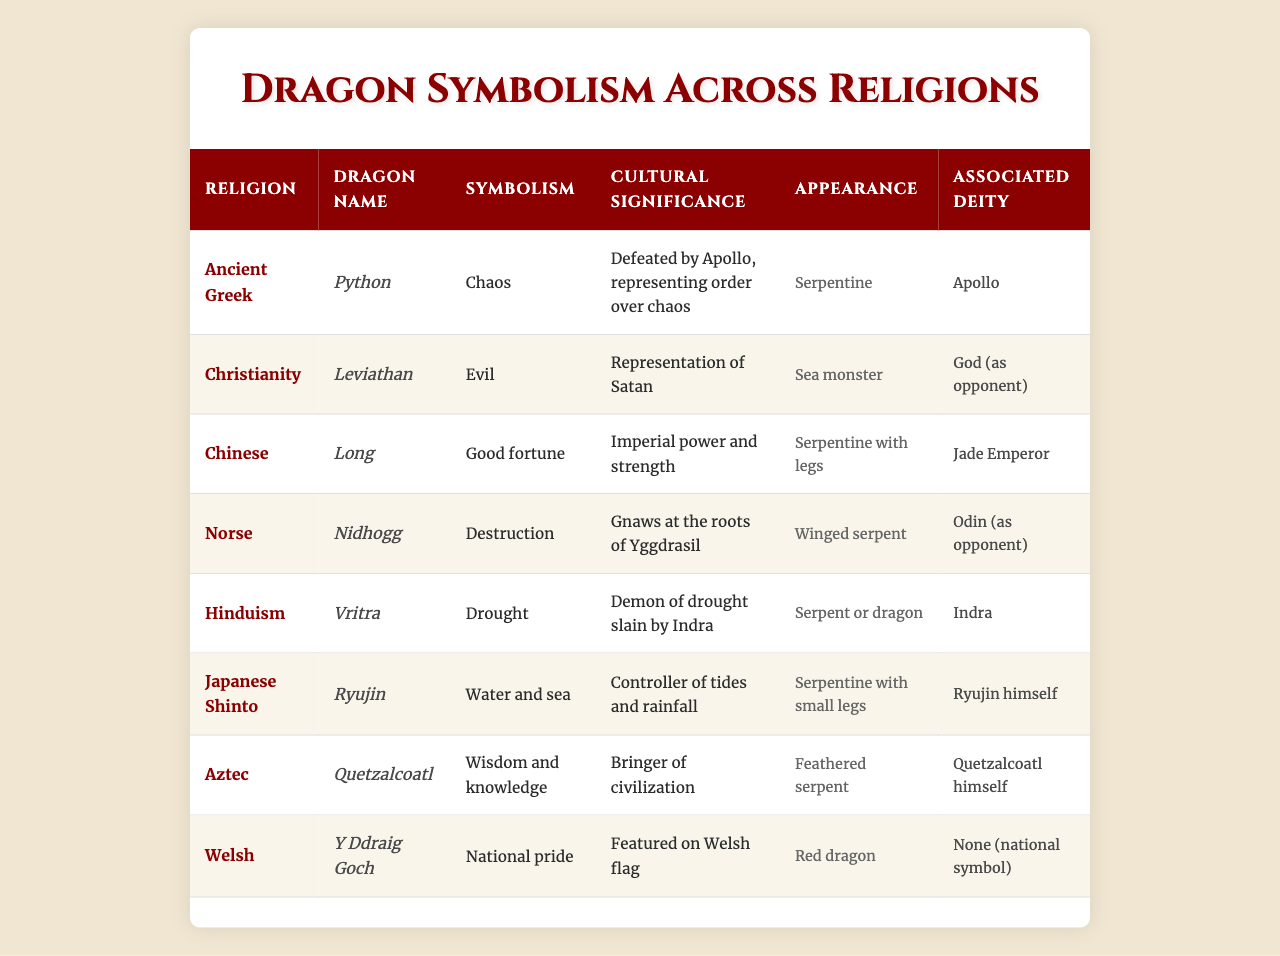What is the symbolism associated with the dragon Leviathan in Christianity? According to the table, the symbolism of Leviathan in Christianity is "Evil."
Answer: Evil Which dragon is associated with the deity Odin in Norse mythology? The table shows that Nidhogg is the dragon associated with Odin.
Answer: Nidhogg What is the cultural significance of the Chinese dragon Long? The cultural significance of Long in Chinese mythology is "Imperial power and strength."
Answer: Imperial power and strength Is the dragon Y Ddraig Goch a national symbol for Wales? The table indicates that Y Ddraig Goch is indeed a national symbol for Wales.
Answer: Yes Which dragon represents chaos in Ancient Greek mythology? According to the table, the dragon Python represents chaos in Ancient Greek mythology.
Answer: Python How many dragon names are listed for religions that symbolize good fortune? The table lists one dragon name associated with good fortune, which is Long in Chinese culture.
Answer: 1 What do the appearances of the dragons in the table generally represent? The table categorizes dragon appearances into various forms, mainly serpentine, indicating a general association with mythic creatures derived from snakes.
Answer: Serpentine and varied Which dragon in the table is depicted as a feathered serpent and symbolizes wisdom? The table specifies Quetzalcoatl as the dragon depicted as a feathered serpent symbolizing wisdom in Aztec mythology.
Answer: Quetzalcoatl What is the common symbolism among dragons in different cultures according to the table? The table reveals that dragons universally share themes of power, either as protectors or destroyers, emphasizing duality in their symbolic representations.
Answer: Power duality Do any dragons in the table symbolize destruction? Yes, the dragon Nidhogg symbolizes destruction according to the table.
Answer: Yes What can be inferred about the representation of dragons across religions? The table indicates that dragons are represented variably as symbols of both good and evil, as well as nature's forces, suggesting diverse cultural interpretations.
Answer: Diverse cultural interpretations 